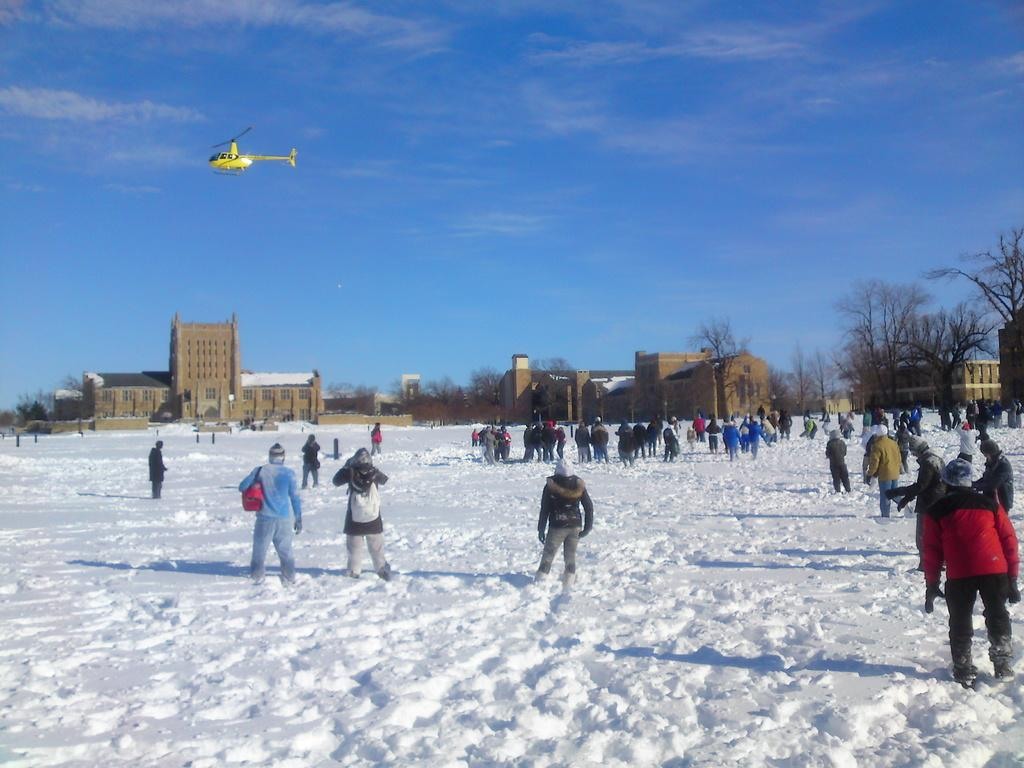What is the surface that the group of people is standing on in the image? The group of people is standing on snow in the image. What type of natural elements can be seen in the image? There are trees in the image. What type of structures are visible in the image? There are buildings with windows in the image. What is happening in the sky in the background of the image? A helicopter is flying in the sky in the background. What is visible in the sky besides the helicopter? Clouds are visible in the sky. What type of learning is taking place in the yard in the image? There is no yard or learning activity present in the image. What type of writing can be seen on the buildings in the image? There is no writing visible on the buildings in the image. 